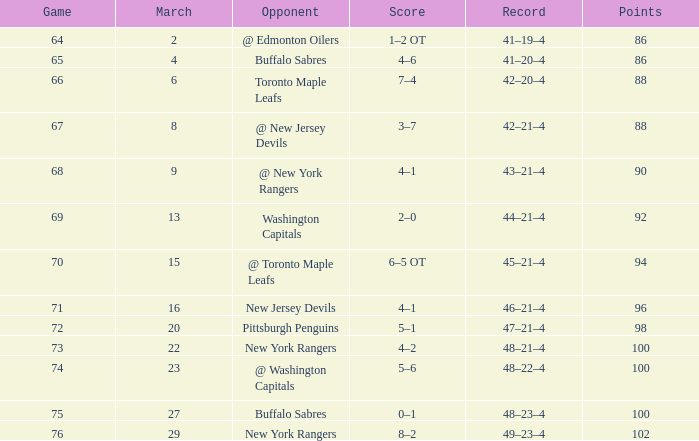Which Opponent has a Record of 45–21–4? @ Toronto Maple Leafs. 